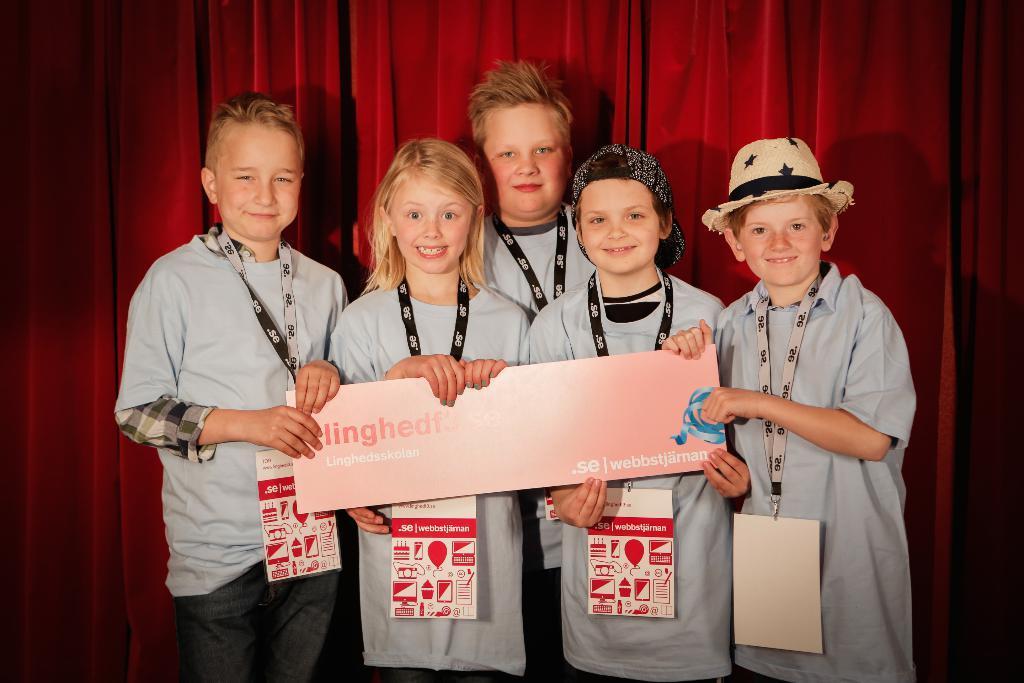Describe this image in one or two sentences. In the center of the image there are children standing wearing Id cards. There are holding a board with some text. In the background of the image there is a red color curtain. 